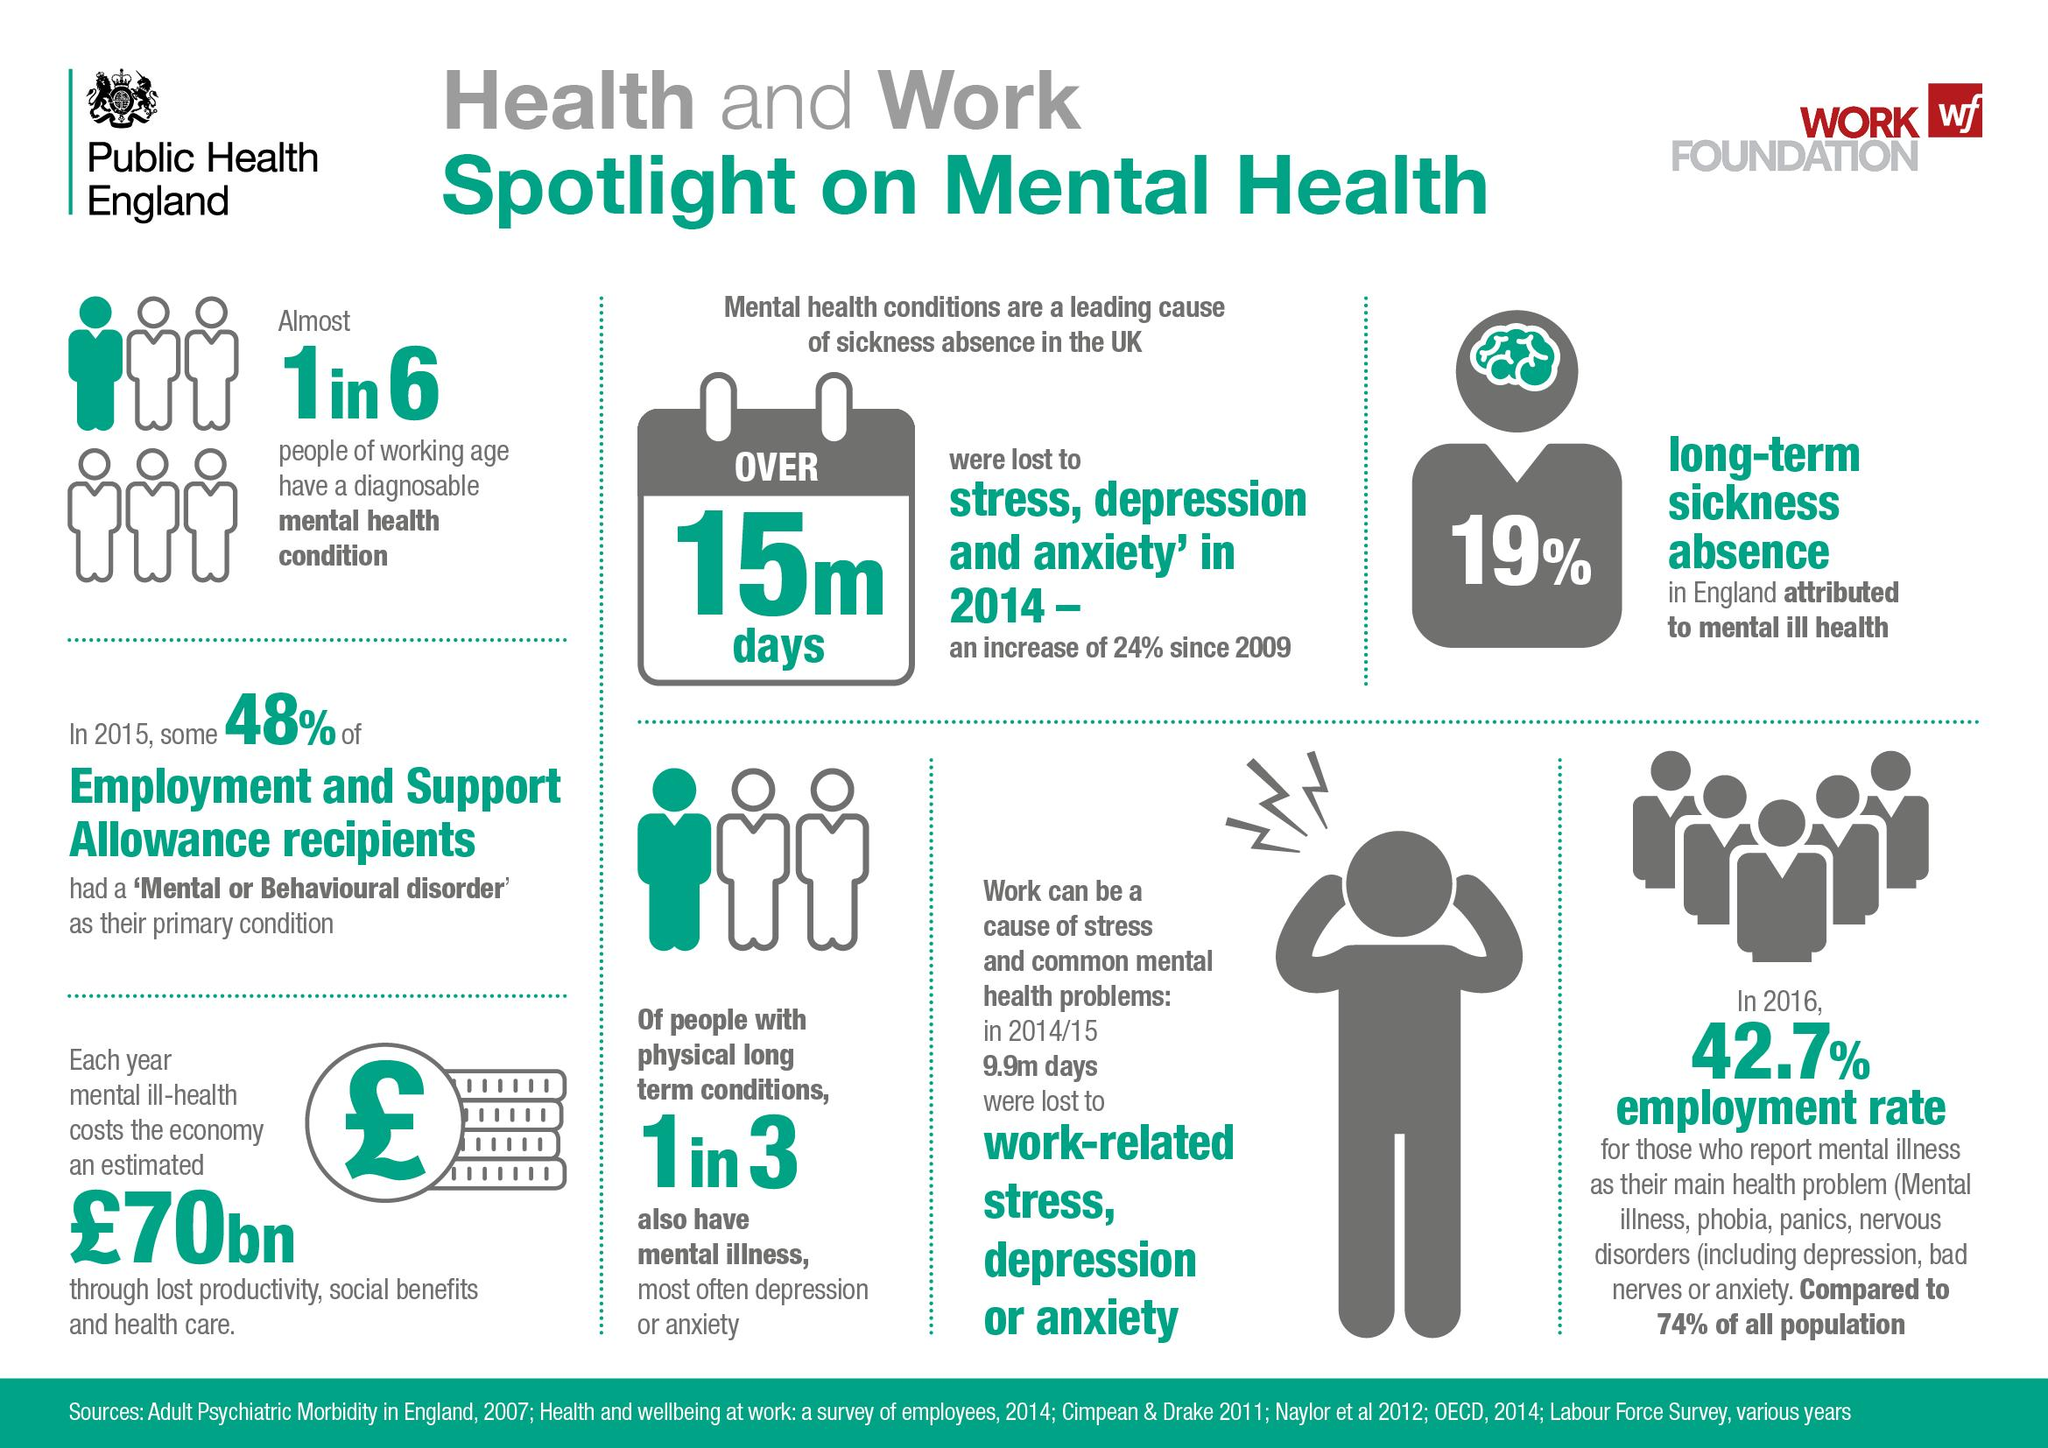Highlight a few significant elements in this photo. In the 2014/15 period, a total of 9.9 million days were lost due to work-related stress, depression, or anxiety. According to a recent study, one third of individuals with physical long-term conditions also suffer from mental illness. The economy is losing approximately 70 billion pounds annually due to mental ill-health, resulting from the significant impact on productivity, the cost of social benefits, and healthcare expenditures. In 2014, an estimated 15 million days were lost due to mental health conditions. The color of the brain is green, not yellow. 